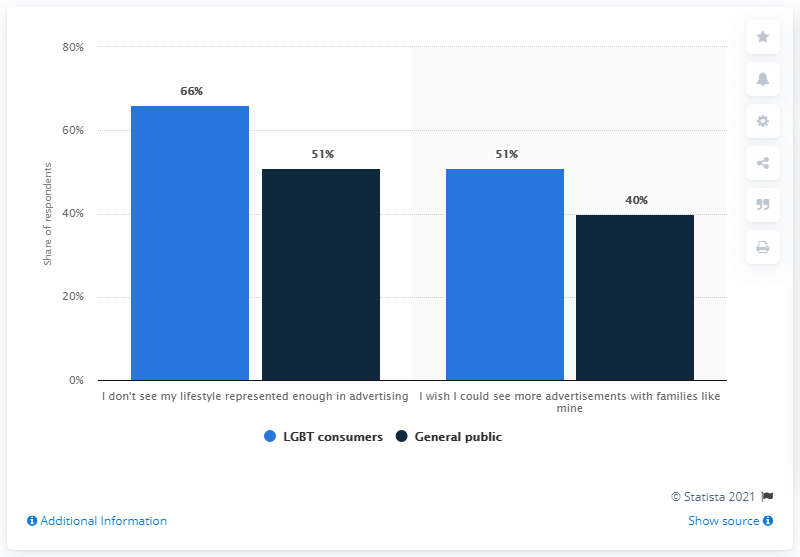Mention a couple of crucial points in this snapshot. The disparity between the viewpoints of LGBT consumers and the general public regarding advertisements featuring families like their own is the least among all opinions. According to a survey, 66% of LGBT consumers feel that their lifestyle is not adequately represented in advertising. 